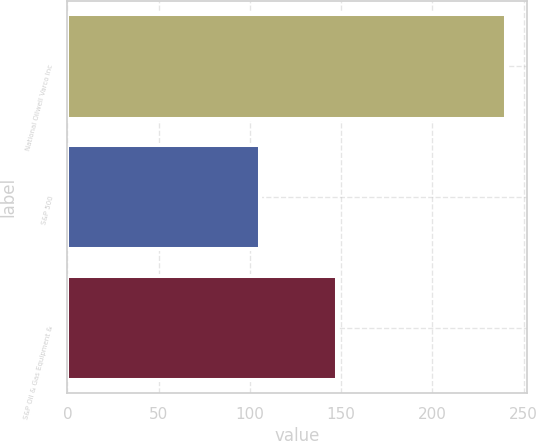<chart> <loc_0><loc_0><loc_500><loc_500><bar_chart><fcel>National Oilwell Varco Inc<fcel>S&P 500<fcel>S&P Oil & Gas Equipment &<nl><fcel>240.14<fcel>105.49<fcel>147.9<nl></chart> 